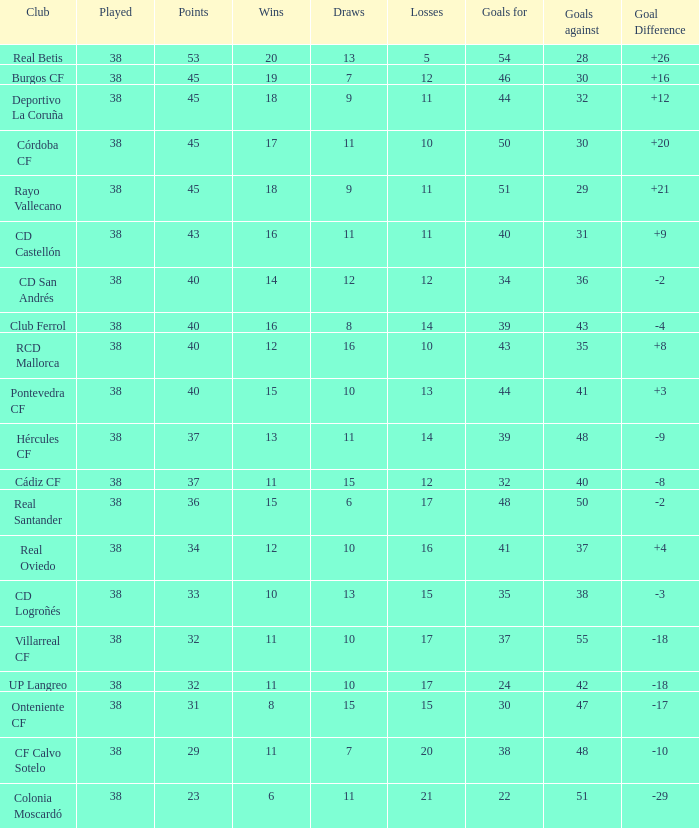What is the highest Goals Against, when Club is "Pontevedra CF", and when Played is less than 38? None. 